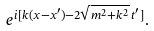<formula> <loc_0><loc_0><loc_500><loc_500>e ^ { i [ k ( x - x ^ { \prime } ) - 2 \sqrt { m ^ { 2 } + k ^ { 2 } } \, t ^ { \prime } ] } .</formula> 